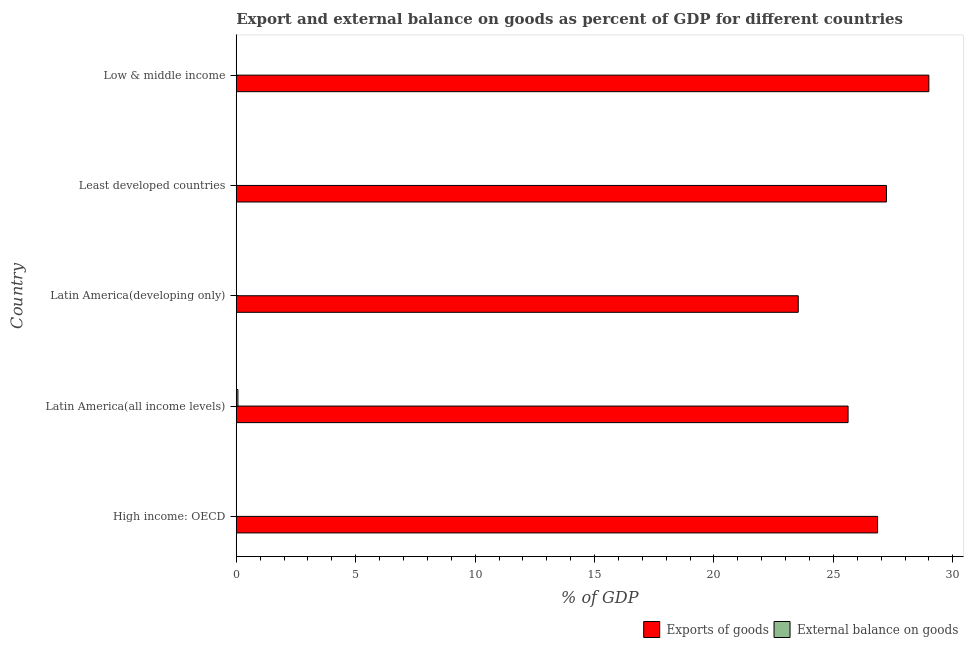How many different coloured bars are there?
Give a very brief answer. 2. Are the number of bars on each tick of the Y-axis equal?
Ensure brevity in your answer.  No. How many bars are there on the 2nd tick from the top?
Your response must be concise. 1. How many bars are there on the 5th tick from the bottom?
Your answer should be very brief. 1. What is the label of the 1st group of bars from the top?
Offer a terse response. Low & middle income. What is the export of goods as percentage of gdp in Low & middle income?
Offer a terse response. 29. Across all countries, what is the maximum export of goods as percentage of gdp?
Keep it short and to the point. 29. Across all countries, what is the minimum external balance on goods as percentage of gdp?
Offer a very short reply. 0. In which country was the external balance on goods as percentage of gdp maximum?
Make the answer very short. Latin America(all income levels). What is the total export of goods as percentage of gdp in the graph?
Give a very brief answer. 132.21. What is the difference between the export of goods as percentage of gdp in Latin America(developing only) and that in Low & middle income?
Ensure brevity in your answer.  -5.47. What is the difference between the export of goods as percentage of gdp in Low & middle income and the external balance on goods as percentage of gdp in High income: OECD?
Your answer should be very brief. 29. What is the average external balance on goods as percentage of gdp per country?
Offer a very short reply. 0.01. What is the difference between the external balance on goods as percentage of gdp and export of goods as percentage of gdp in Latin America(all income levels)?
Give a very brief answer. -25.54. What is the ratio of the export of goods as percentage of gdp in High income: OECD to that in Low & middle income?
Offer a terse response. 0.93. What is the difference between the highest and the second highest export of goods as percentage of gdp?
Give a very brief answer. 1.77. What is the difference between the highest and the lowest external balance on goods as percentage of gdp?
Make the answer very short. 0.07. In how many countries, is the export of goods as percentage of gdp greater than the average export of goods as percentage of gdp taken over all countries?
Offer a very short reply. 3. Is the sum of the export of goods as percentage of gdp in Latin America(all income levels) and Latin America(developing only) greater than the maximum external balance on goods as percentage of gdp across all countries?
Keep it short and to the point. Yes. How many bars are there?
Offer a very short reply. 6. How many countries are there in the graph?
Provide a succinct answer. 5. Are the values on the major ticks of X-axis written in scientific E-notation?
Ensure brevity in your answer.  No. Does the graph contain any zero values?
Give a very brief answer. Yes. Does the graph contain grids?
Offer a very short reply. No. Where does the legend appear in the graph?
Your answer should be compact. Bottom right. How are the legend labels stacked?
Give a very brief answer. Horizontal. What is the title of the graph?
Keep it short and to the point. Export and external balance on goods as percent of GDP for different countries. What is the label or title of the X-axis?
Ensure brevity in your answer.  % of GDP. What is the % of GDP of Exports of goods in High income: OECD?
Offer a very short reply. 26.85. What is the % of GDP of External balance on goods in High income: OECD?
Keep it short and to the point. 0. What is the % of GDP of Exports of goods in Latin America(all income levels)?
Make the answer very short. 25.61. What is the % of GDP in External balance on goods in Latin America(all income levels)?
Your response must be concise. 0.07. What is the % of GDP of Exports of goods in Latin America(developing only)?
Your response must be concise. 23.53. What is the % of GDP in External balance on goods in Latin America(developing only)?
Provide a short and direct response. 0. What is the % of GDP in Exports of goods in Least developed countries?
Provide a succinct answer. 27.22. What is the % of GDP in External balance on goods in Least developed countries?
Your response must be concise. 0. What is the % of GDP of Exports of goods in Low & middle income?
Keep it short and to the point. 29. What is the % of GDP in External balance on goods in Low & middle income?
Make the answer very short. 0. Across all countries, what is the maximum % of GDP in Exports of goods?
Your response must be concise. 29. Across all countries, what is the maximum % of GDP of External balance on goods?
Provide a short and direct response. 0.07. Across all countries, what is the minimum % of GDP in Exports of goods?
Your answer should be very brief. 23.53. What is the total % of GDP in Exports of goods in the graph?
Your response must be concise. 132.21. What is the total % of GDP of External balance on goods in the graph?
Provide a succinct answer. 0.07. What is the difference between the % of GDP of Exports of goods in High income: OECD and that in Latin America(all income levels)?
Give a very brief answer. 1.24. What is the difference between the % of GDP in Exports of goods in High income: OECD and that in Latin America(developing only)?
Make the answer very short. 3.32. What is the difference between the % of GDP in Exports of goods in High income: OECD and that in Least developed countries?
Your answer should be compact. -0.37. What is the difference between the % of GDP in Exports of goods in High income: OECD and that in Low & middle income?
Your response must be concise. -2.15. What is the difference between the % of GDP in Exports of goods in Latin America(all income levels) and that in Latin America(developing only)?
Your response must be concise. 2.09. What is the difference between the % of GDP of Exports of goods in Latin America(all income levels) and that in Least developed countries?
Your answer should be compact. -1.61. What is the difference between the % of GDP of Exports of goods in Latin America(all income levels) and that in Low & middle income?
Offer a terse response. -3.38. What is the difference between the % of GDP in Exports of goods in Latin America(developing only) and that in Least developed countries?
Give a very brief answer. -3.69. What is the difference between the % of GDP in Exports of goods in Latin America(developing only) and that in Low & middle income?
Provide a short and direct response. -5.47. What is the difference between the % of GDP in Exports of goods in Least developed countries and that in Low & middle income?
Offer a terse response. -1.77. What is the difference between the % of GDP of Exports of goods in High income: OECD and the % of GDP of External balance on goods in Latin America(all income levels)?
Give a very brief answer. 26.78. What is the average % of GDP in Exports of goods per country?
Your answer should be very brief. 26.44. What is the average % of GDP of External balance on goods per country?
Offer a very short reply. 0.01. What is the difference between the % of GDP in Exports of goods and % of GDP in External balance on goods in Latin America(all income levels)?
Make the answer very short. 25.54. What is the ratio of the % of GDP of Exports of goods in High income: OECD to that in Latin America(all income levels)?
Keep it short and to the point. 1.05. What is the ratio of the % of GDP in Exports of goods in High income: OECD to that in Latin America(developing only)?
Provide a succinct answer. 1.14. What is the ratio of the % of GDP of Exports of goods in High income: OECD to that in Least developed countries?
Your answer should be very brief. 0.99. What is the ratio of the % of GDP of Exports of goods in High income: OECD to that in Low & middle income?
Your response must be concise. 0.93. What is the ratio of the % of GDP in Exports of goods in Latin America(all income levels) to that in Latin America(developing only)?
Make the answer very short. 1.09. What is the ratio of the % of GDP of Exports of goods in Latin America(all income levels) to that in Least developed countries?
Provide a short and direct response. 0.94. What is the ratio of the % of GDP in Exports of goods in Latin America(all income levels) to that in Low & middle income?
Your answer should be compact. 0.88. What is the ratio of the % of GDP of Exports of goods in Latin America(developing only) to that in Least developed countries?
Ensure brevity in your answer.  0.86. What is the ratio of the % of GDP in Exports of goods in Latin America(developing only) to that in Low & middle income?
Offer a terse response. 0.81. What is the ratio of the % of GDP of Exports of goods in Least developed countries to that in Low & middle income?
Provide a succinct answer. 0.94. What is the difference between the highest and the second highest % of GDP of Exports of goods?
Your answer should be compact. 1.77. What is the difference between the highest and the lowest % of GDP of Exports of goods?
Your response must be concise. 5.47. What is the difference between the highest and the lowest % of GDP of External balance on goods?
Make the answer very short. 0.07. 